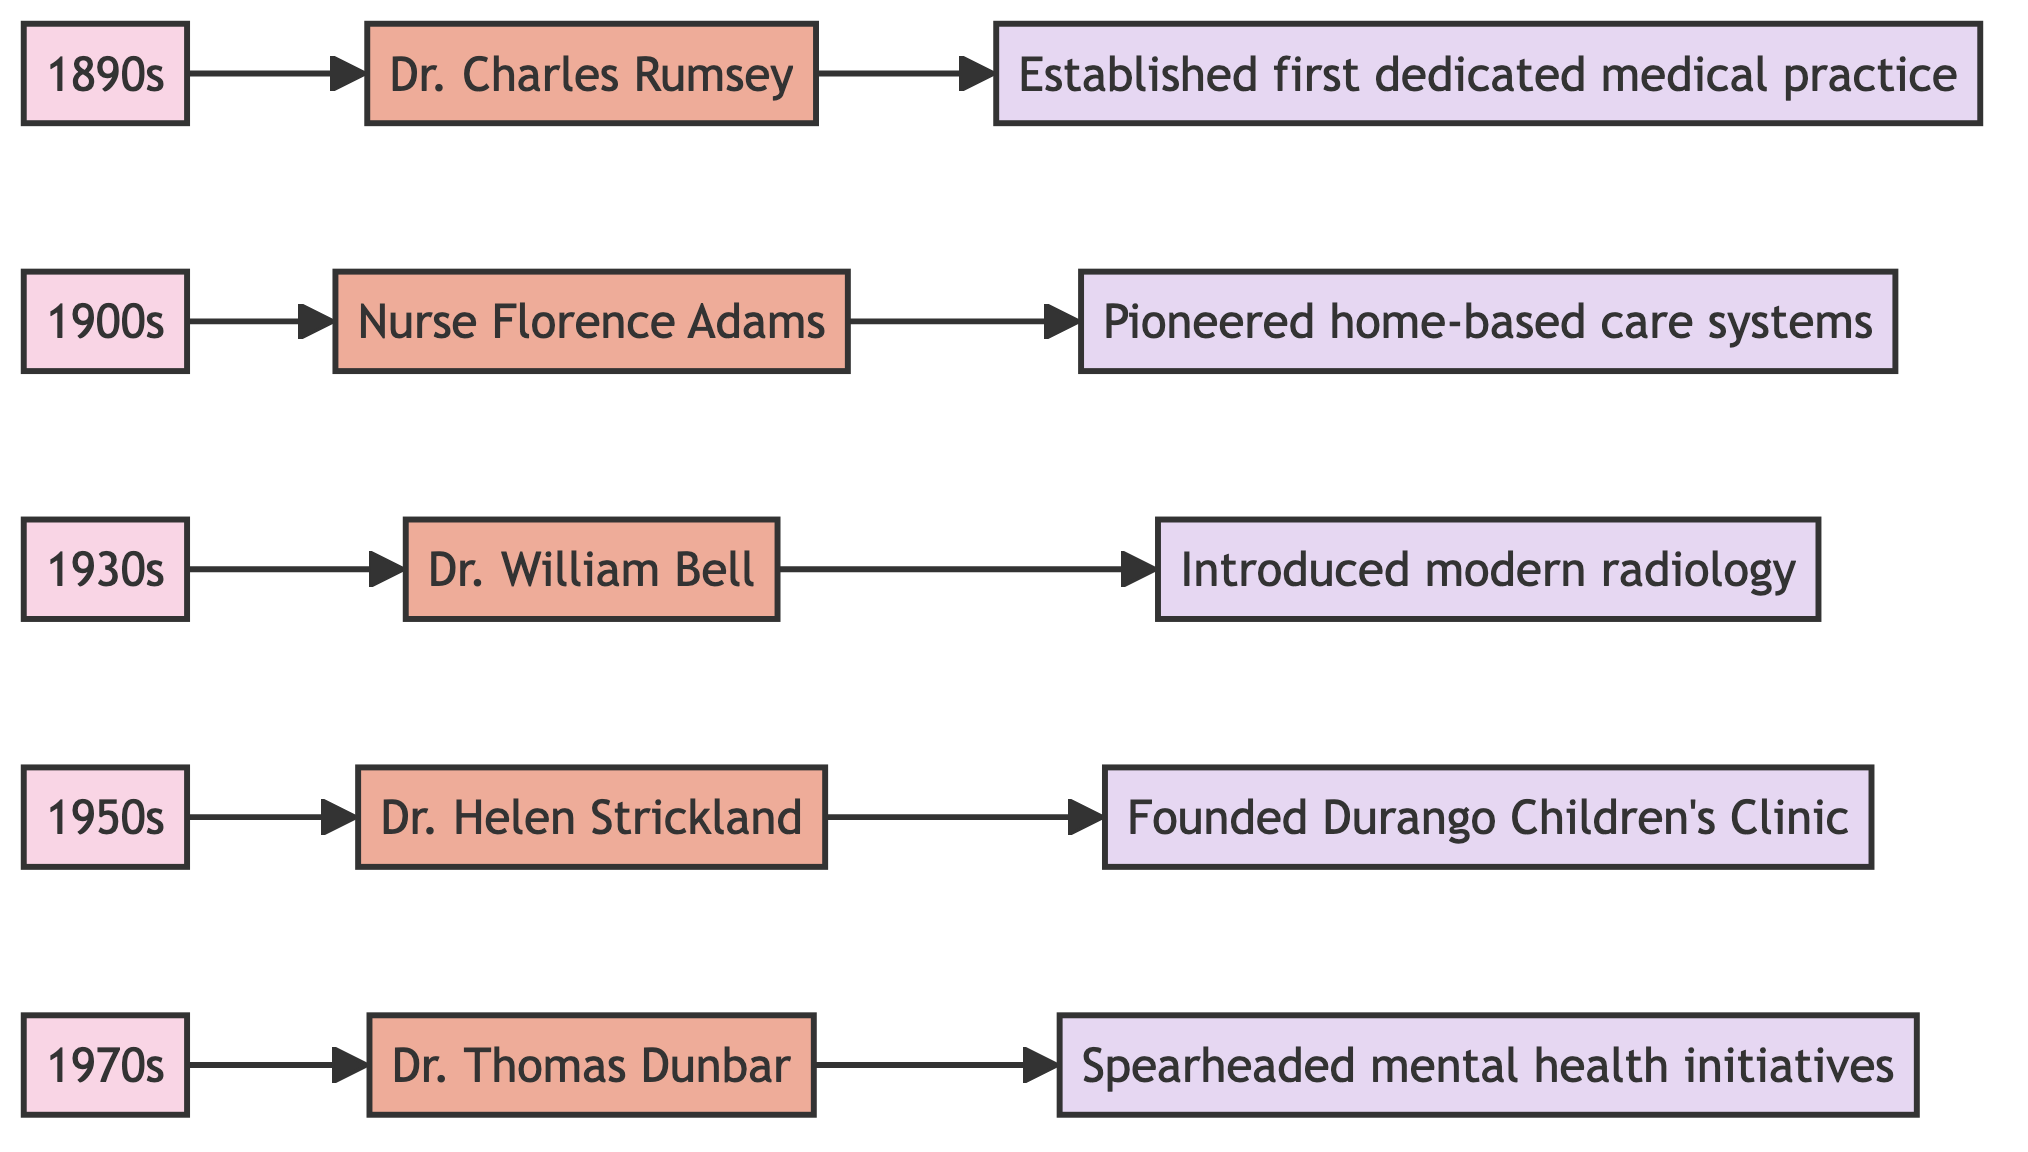What is the earliest era represented in the diagram? The diagram shows nodes labeled with eras, starting from 1890s. The first era node in the flowchart indicates this is the earliest time period represented.
Answer: 1890s How many historical figures are included in the diagram? By counting the number of distinct figure nodes connected to the eras, I identify five different historical figures: Rumsey, Adams, Bell, Strickland, and Dunbar.
Answer: 5 What contribution is associated with Dr. William Bell? Directly following the node for Dr. William Bell is a connection labeled "Introduced modern radiology," indicating his specific contribution to Durango's medical history.
Answer: Introduced modern radiology Who founded the Durango Children's Clinic? The diagram specifies that Dr. Helen Strickland is connected to the contribution "Founded Durango Children's Clinic," clearly associating her with this establishment.
Answer: Dr. Helen Strickland In which decade did Nurse Florence Adams make her contributions? The diagram connects Nurse Florence Adams to the node labeled 1900s, indicating the specific decade when she was active in her contributions.
Answer: 1900s What type of initiatives did Dr. Thomas Dunbar spearhead? The contribution linked to Dr. Thomas Dunbar is "Spearheaded mental health initiatives," which clarifies the focus of his efforts in the community.
Answer: Mental health initiatives Which historical figure is associated with establishing home-based care systems? The connection from Nurse Florence Adams leads to the contribution "Pioneered home-based care systems," specifying her role in this area of healthcare.
Answer: Nurse Florence Adams Which two figures from the diagram focus on child health? Reviewing the contributions mapped out, both Dr. Helen Strickland (children's clinic) and Nurse Florence Adams (home care during flu outbreaks) address aspects of child health.
Answer: Dr. Helen Strickland and Nurse Florence Adams What is the link between historical figures and their contributions in the diagram? The diagram shows a linear connection from each historical figure node to their respective contribution nodes, illustrating a direct association between individuals and their impacts on Durango's medical history.
Answer: Linear connection 